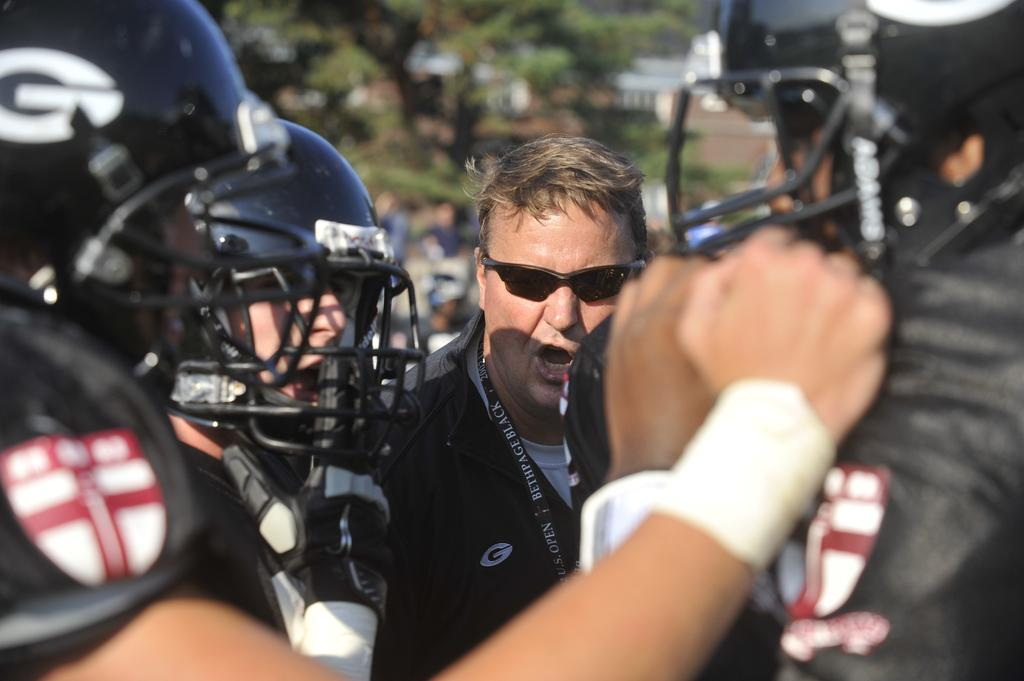What can be seen in the foreground of the image? There are persons in the foreground of the image. What protective gear are some of the persons wearing? Some persons are wearing helmets. Can you describe the appearance of one person in the image? One person is wearing spectacles. What type of vegetation is visible at the top of the image? Trees are visible at the top of the image. Can you see any ghosts in the image? There are no ghosts present in the image. What type of worm can be seen crawling on the person wearing spectacles? There are no worms present in the image. 